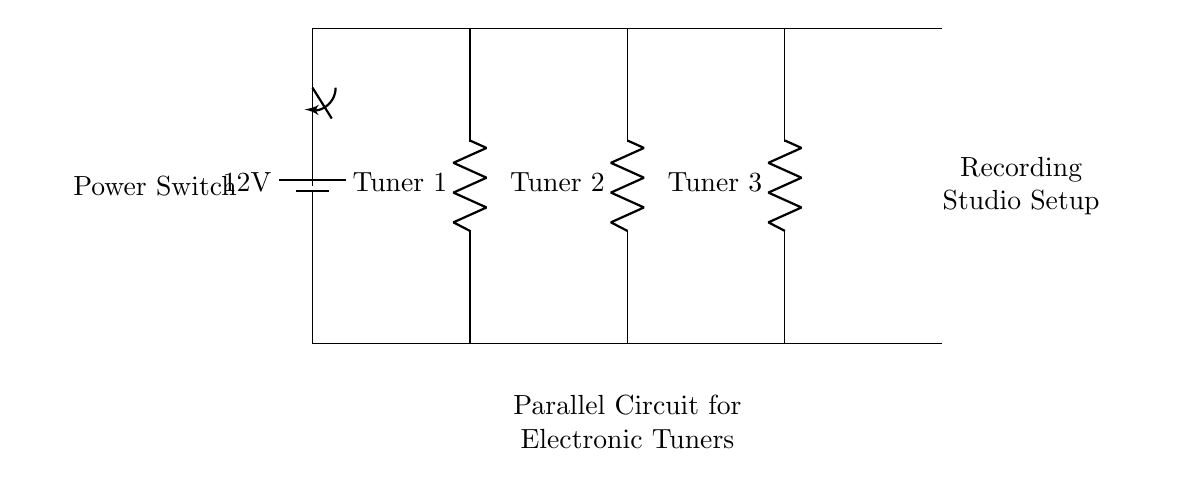What is the total voltage supplied to the circuit? The total voltage of the circuit is 12 volts, as indicated by the battery label in the diagram.
Answer: 12 volts How many electronic tuners are there in the circuit? The circuit shows three electronic tuners identified as Tuner 1, Tuner 2, and Tuner 3.
Answer: Three What type of circuit is this? This is a parallel circuit because the electronic tuners are connected across the same voltage source independently.
Answer: Parallel What is the role of the power switch in this circuit? The power switch controls the power flow to the entire circuit, allowing the operator to turn on or off all tuners simultaneously.
Answer: To control power What happens to the current if one tuner fails? In a parallel circuit, if one tuner fails, the other tuners continue to function normally because they have their own direct path to the power source.
Answer: Other tuners remain functional What is the current path for Tuner 2? The current flows from the battery through the top line to Tuner 2 and returns through the bottom line, creating a complete loop for Tuner 2.
Answer: Through the designated path What is the function of a parallel circuit layout in this setup? A parallel circuit layout allows each electronic tuner to operate independently at the same voltage without affecting others, optimizing functionality in a recording studio.
Answer: Independent operation 